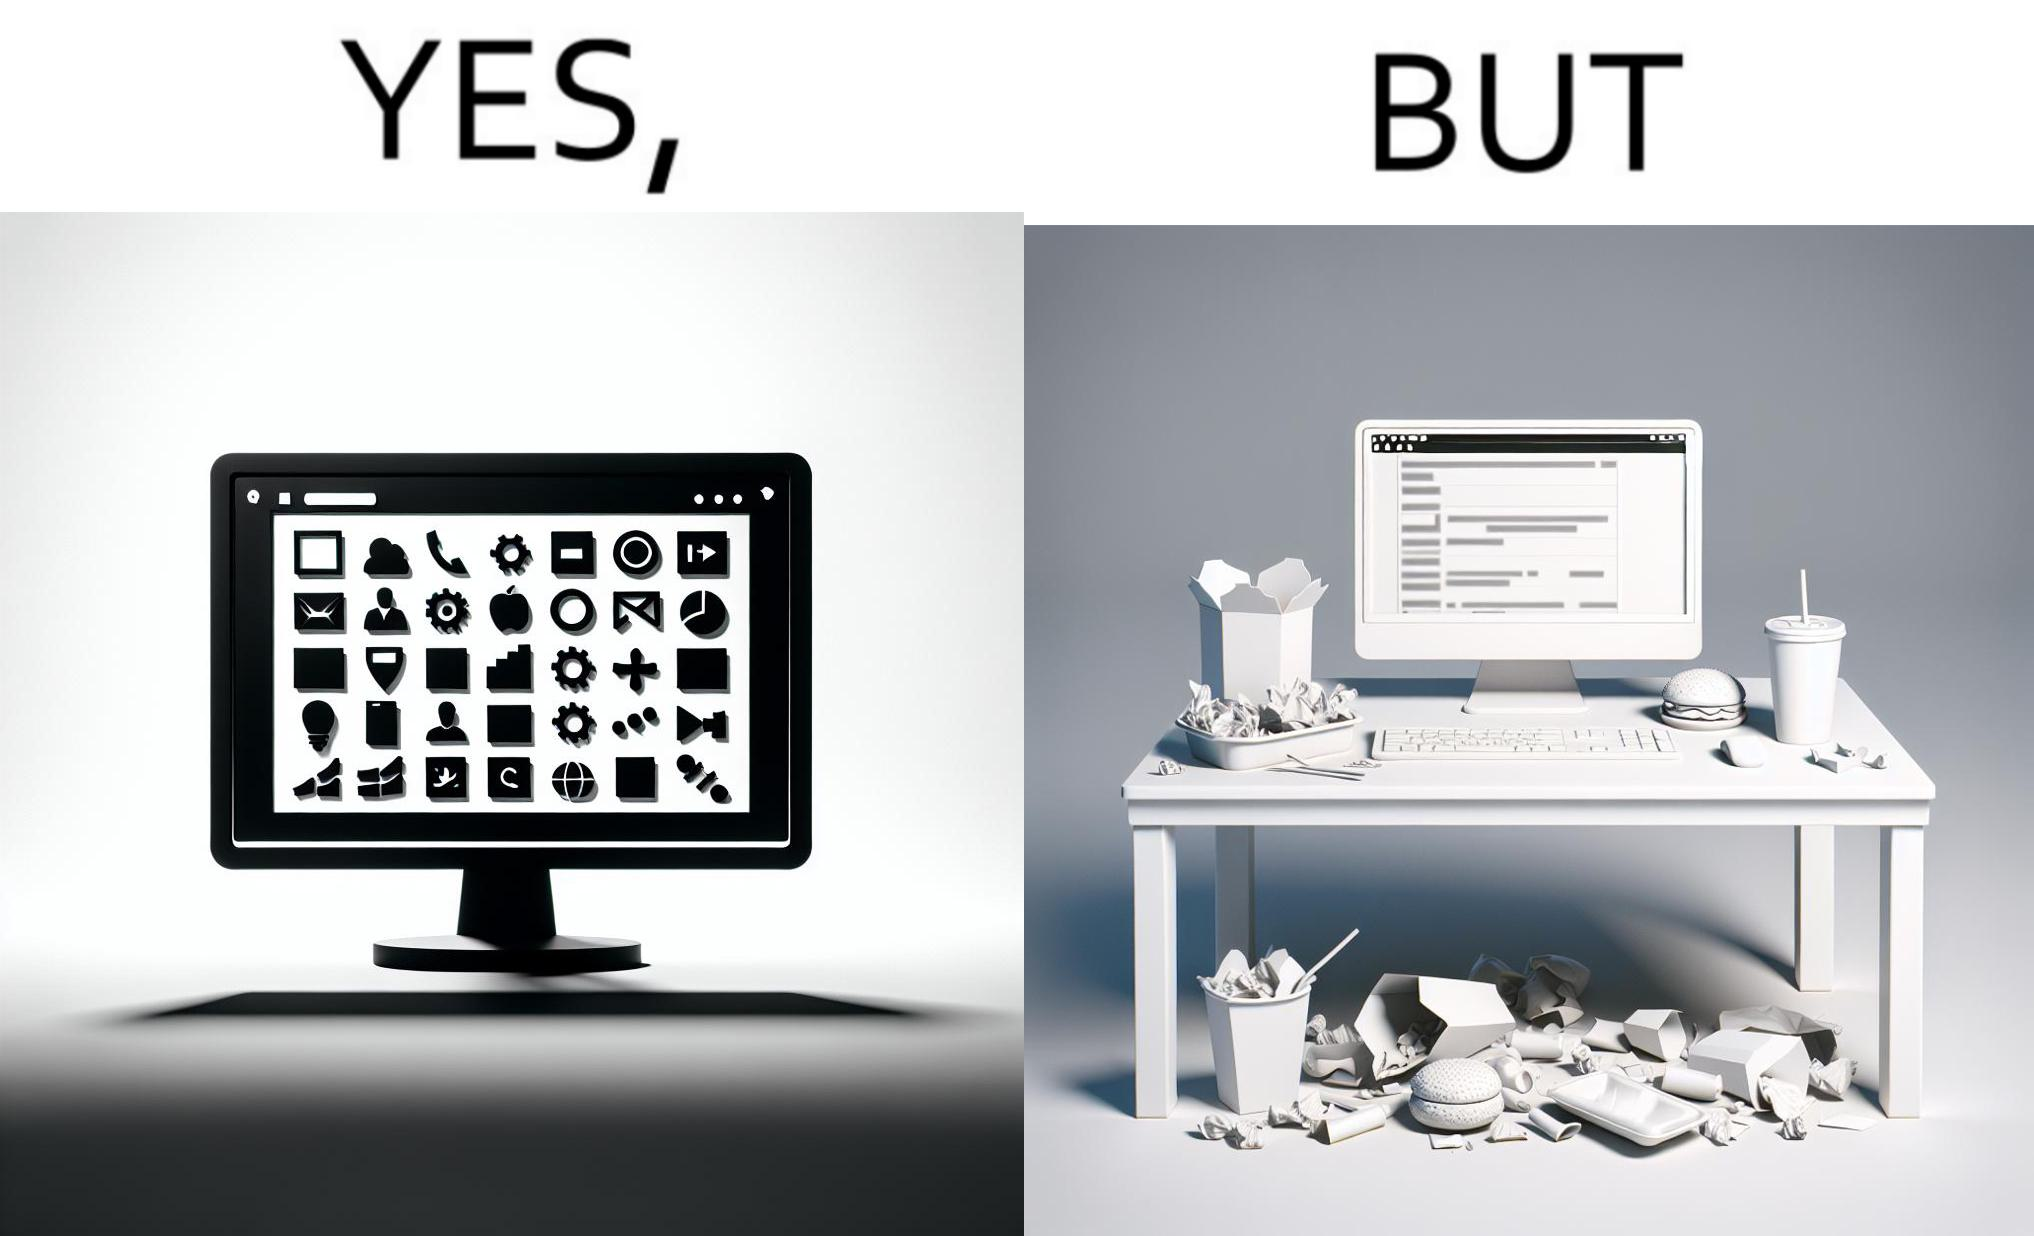Provide a description of this image. The image is ironical, as the folder icons on the desktop screen are very neatly arranged, while the person using the computer has littered the table with used food packets, dirty plates, and wrappers. 